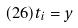Convert formula to latex. <formula><loc_0><loc_0><loc_500><loc_500>( 2 6 ) t _ { i } = y</formula> 